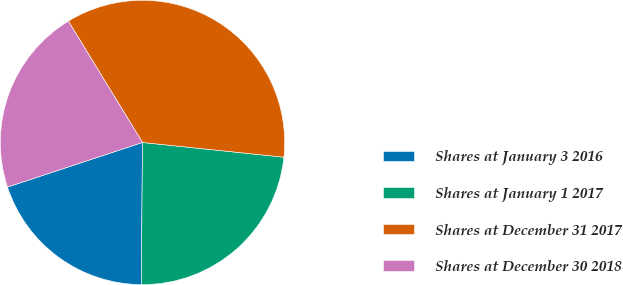Convert chart to OTSL. <chart><loc_0><loc_0><loc_500><loc_500><pie_chart><fcel>Shares at January 3 2016<fcel>Shares at January 1 2017<fcel>Shares at December 31 2017<fcel>Shares at December 30 2018<nl><fcel>19.79%<fcel>23.48%<fcel>35.38%<fcel>21.35%<nl></chart> 